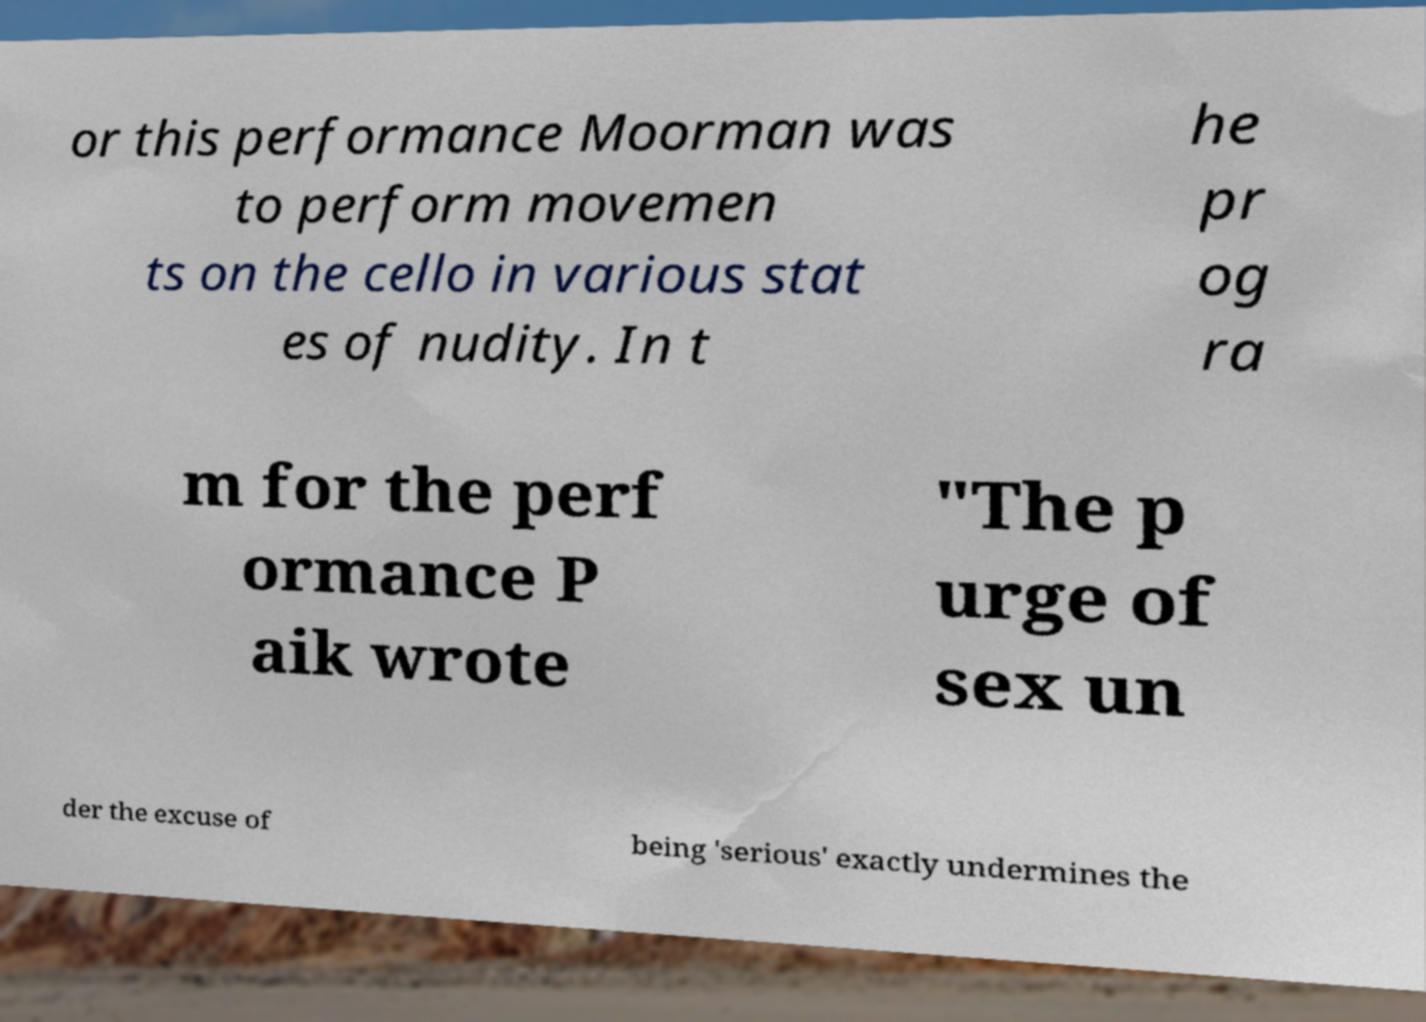Can you read and provide the text displayed in the image?This photo seems to have some interesting text. Can you extract and type it out for me? or this performance Moorman was to perform movemen ts on the cello in various stat es of nudity. In t he pr og ra m for the perf ormance P aik wrote "The p urge of sex un der the excuse of being 'serious' exactly undermines the 